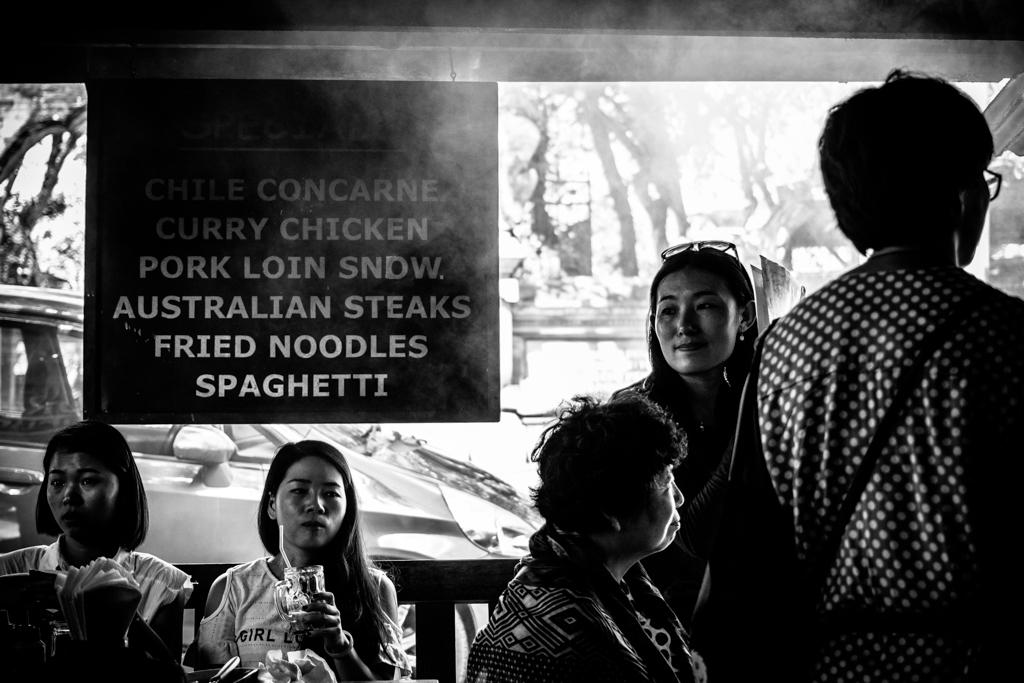What are the people in the image doing? The persons in the image are sitting and standing on the floor. What can be seen on the information board in the image? The information on the board cannot be determined from the image. What type of vehicles are present in the image? Motor vehicles are present in the image. What might be used for cleaning or wiping in the image? Paper napkins are visible in the image. What type of vegetation is in the image? There are trees in the image. What is visible in the sky in the image? The sky is visible in the image. Can you tell me how many owls are sitting on the motor vehicles in the image? There are no owls present in the image; it features people, an information board, motor vehicles, paper napkins, trees, and the sky. What is the purpose of the point on the information board in the image? There is no point mentioned on the information board in the image, and its purpose cannot be determined. 